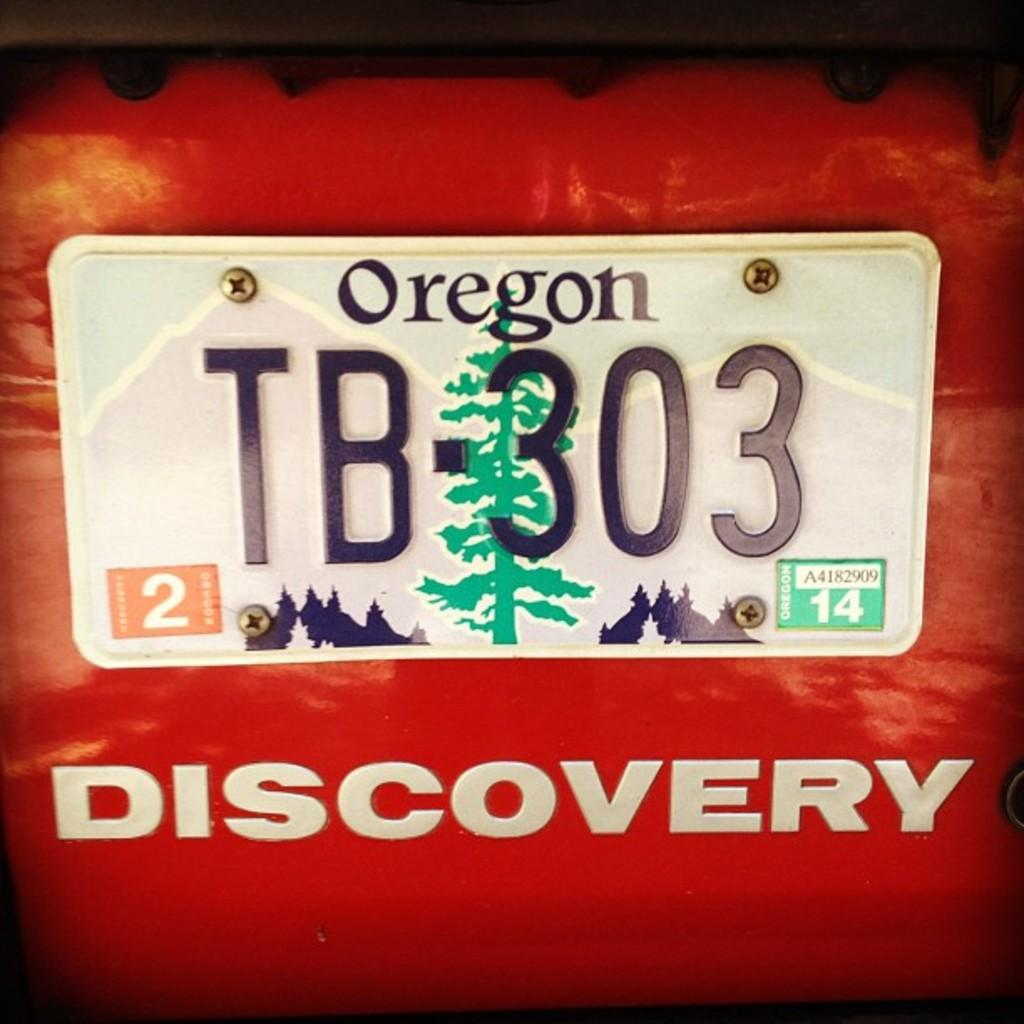Provide a one-sentence caption for the provided image. An Oregon liscense plate on an orange discovery vehicle. 